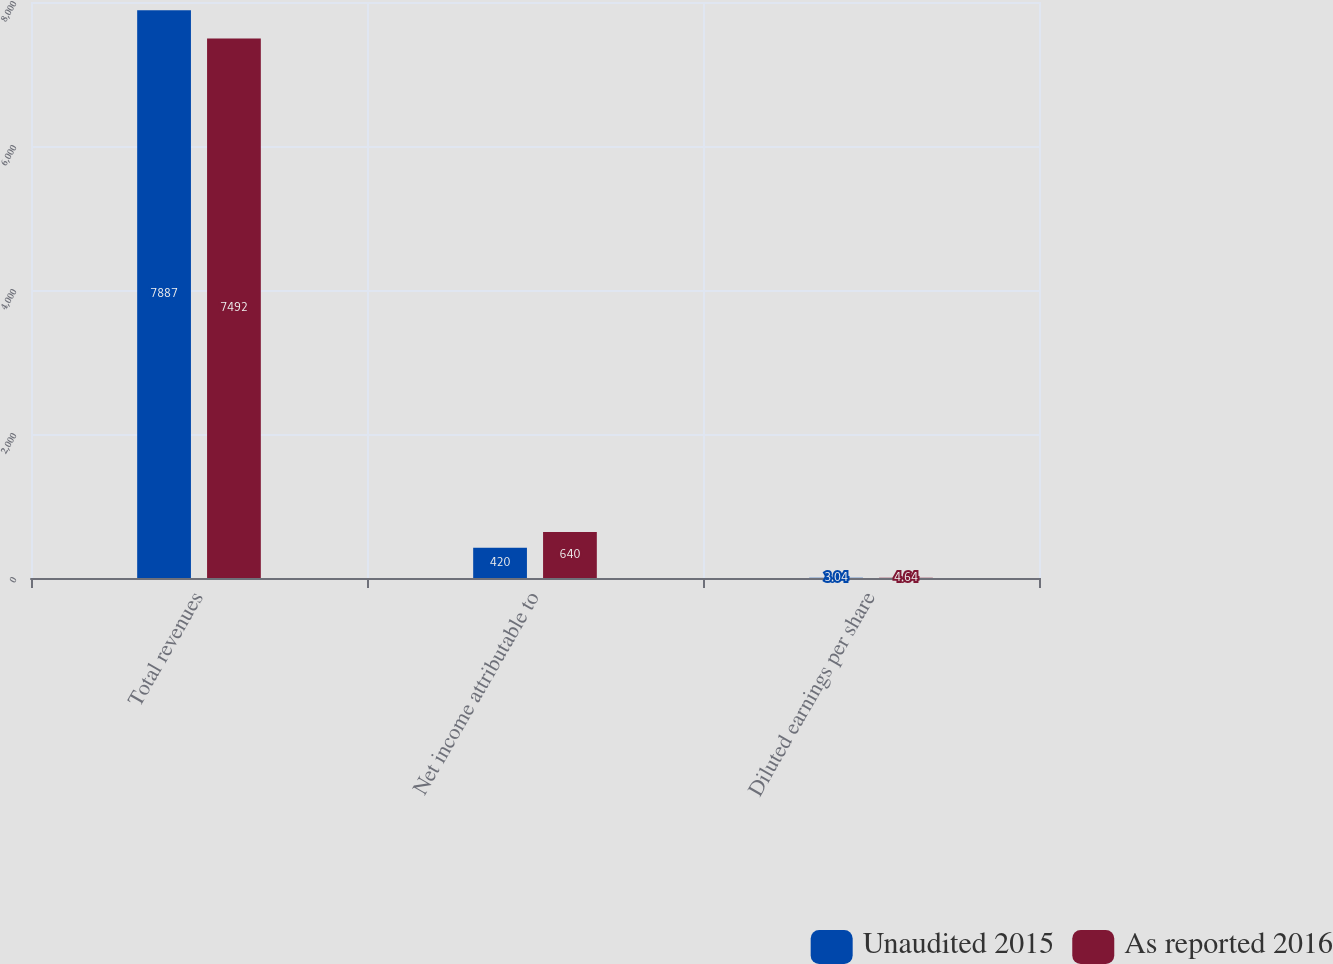Convert chart. <chart><loc_0><loc_0><loc_500><loc_500><stacked_bar_chart><ecel><fcel>Total revenues<fcel>Net income attributable to<fcel>Diluted earnings per share<nl><fcel>Unaudited 2015<fcel>7887<fcel>420<fcel>3.04<nl><fcel>As reported 2016<fcel>7492<fcel>640<fcel>4.64<nl></chart> 